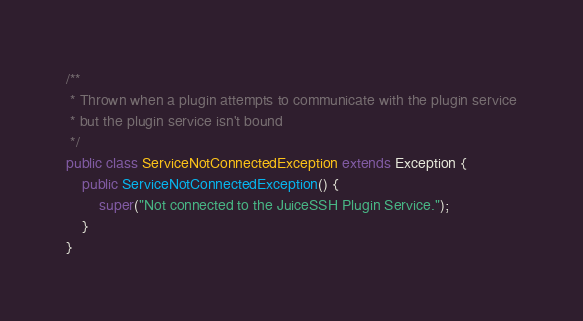Convert code to text. <code><loc_0><loc_0><loc_500><loc_500><_Java_>
/**
 * Thrown when a plugin attempts to communicate with the plugin service
 * but the plugin service isn't bound
 */
public class ServiceNotConnectedException extends Exception {
    public ServiceNotConnectedException() {
        super("Not connected to the JuiceSSH Plugin Service.");
    }
}
</code> 